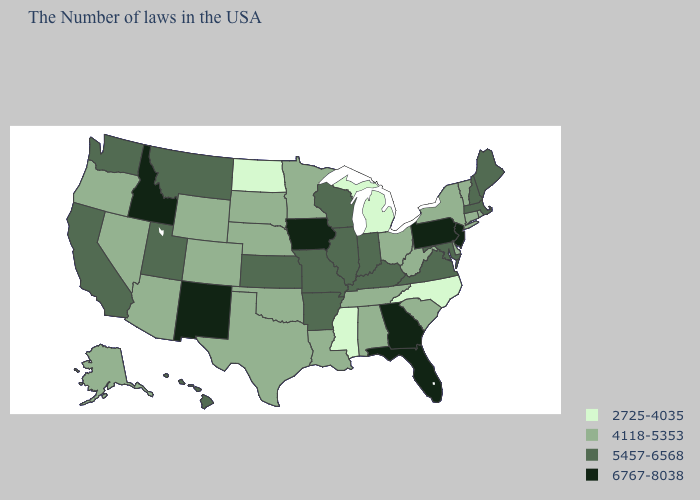How many symbols are there in the legend?
Short answer required. 4. Does the first symbol in the legend represent the smallest category?
Answer briefly. Yes. Among the states that border Montana , does Idaho have the highest value?
Short answer required. Yes. Does the first symbol in the legend represent the smallest category?
Answer briefly. Yes. Among the states that border Georgia , does North Carolina have the lowest value?
Quick response, please. Yes. What is the lowest value in the USA?
Concise answer only. 2725-4035. What is the lowest value in the USA?
Give a very brief answer. 2725-4035. What is the value of Texas?
Quick response, please. 4118-5353. What is the highest value in the West ?
Quick response, please. 6767-8038. Name the states that have a value in the range 5457-6568?
Short answer required. Maine, Massachusetts, New Hampshire, Maryland, Virginia, Kentucky, Indiana, Wisconsin, Illinois, Missouri, Arkansas, Kansas, Utah, Montana, California, Washington, Hawaii. What is the value of Iowa?
Write a very short answer. 6767-8038. Name the states that have a value in the range 6767-8038?
Answer briefly. New Jersey, Pennsylvania, Florida, Georgia, Iowa, New Mexico, Idaho. Name the states that have a value in the range 4118-5353?
Be succinct. Rhode Island, Vermont, Connecticut, New York, Delaware, South Carolina, West Virginia, Ohio, Alabama, Tennessee, Louisiana, Minnesota, Nebraska, Oklahoma, Texas, South Dakota, Wyoming, Colorado, Arizona, Nevada, Oregon, Alaska. Which states have the lowest value in the MidWest?
Short answer required. Michigan, North Dakota. Which states have the lowest value in the MidWest?
Short answer required. Michigan, North Dakota. 